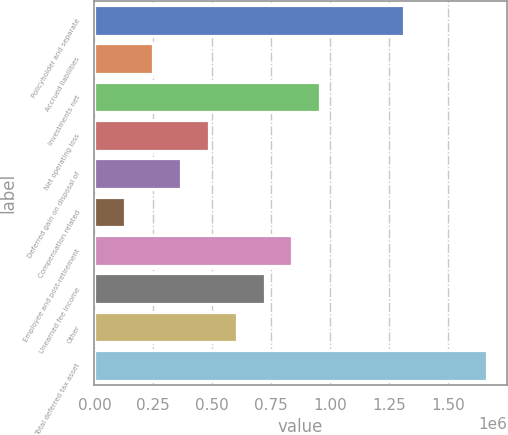<chart> <loc_0><loc_0><loc_500><loc_500><bar_chart><fcel>Policyholder and separate<fcel>Accrued liabilities<fcel>Investments net<fcel>Net operating loss<fcel>Deferred gain on disposal of<fcel>Compensation related<fcel>Employee and post-retirement<fcel>Unearned fee income<fcel>Other<fcel>Total deferred tax asset<nl><fcel>1.31175e+06<fcel>249315<fcel>957608<fcel>485413<fcel>367364<fcel>131267<fcel>839559<fcel>721510<fcel>603462<fcel>1.6659e+06<nl></chart> 